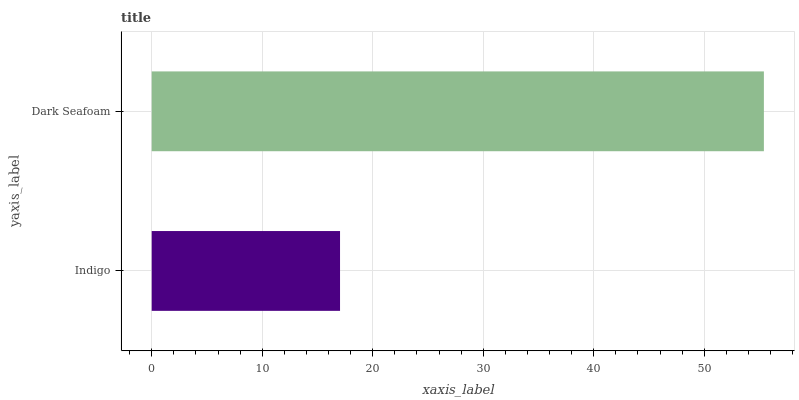Is Indigo the minimum?
Answer yes or no. Yes. Is Dark Seafoam the maximum?
Answer yes or no. Yes. Is Dark Seafoam the minimum?
Answer yes or no. No. Is Dark Seafoam greater than Indigo?
Answer yes or no. Yes. Is Indigo less than Dark Seafoam?
Answer yes or no. Yes. Is Indigo greater than Dark Seafoam?
Answer yes or no. No. Is Dark Seafoam less than Indigo?
Answer yes or no. No. Is Dark Seafoam the high median?
Answer yes or no. Yes. Is Indigo the low median?
Answer yes or no. Yes. Is Indigo the high median?
Answer yes or no. No. Is Dark Seafoam the low median?
Answer yes or no. No. 